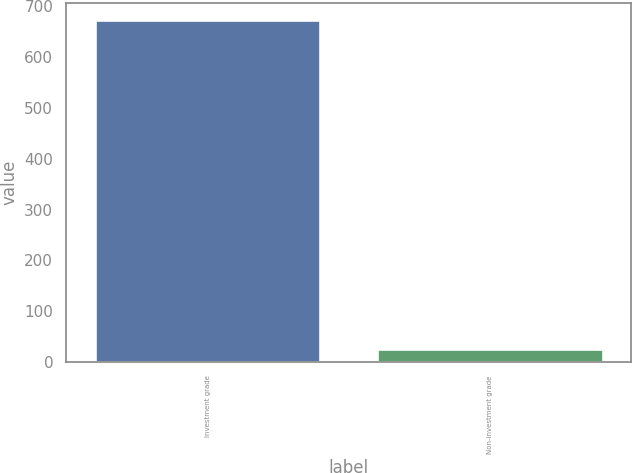Convert chart to OTSL. <chart><loc_0><loc_0><loc_500><loc_500><bar_chart><fcel>Investment grade<fcel>Non-investment grade<nl><fcel>672<fcel>25<nl></chart> 